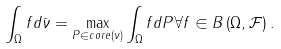<formula> <loc_0><loc_0><loc_500><loc_500>\int _ { \Omega } f d \bar { \nu } = \max _ { P \in c o r e \left ( \nu \right ) } \int _ { \Omega } f d P \forall f \in B \left ( \Omega , \mathcal { F } \right ) .</formula> 